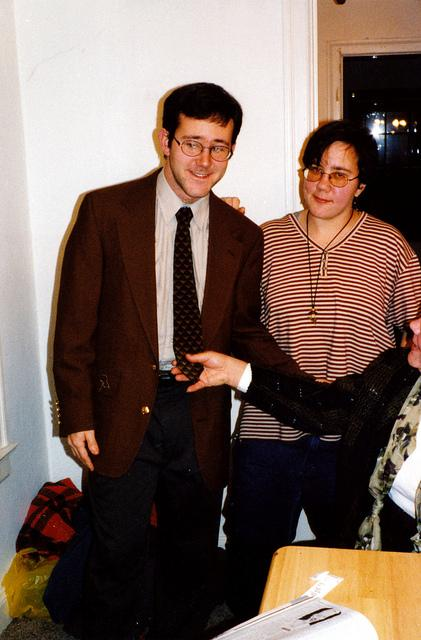What is sometimes substituted for the item the woman is holding?

Choices:
A) cummerbund
B) glove
C) sock
D) bow tie bow tie 